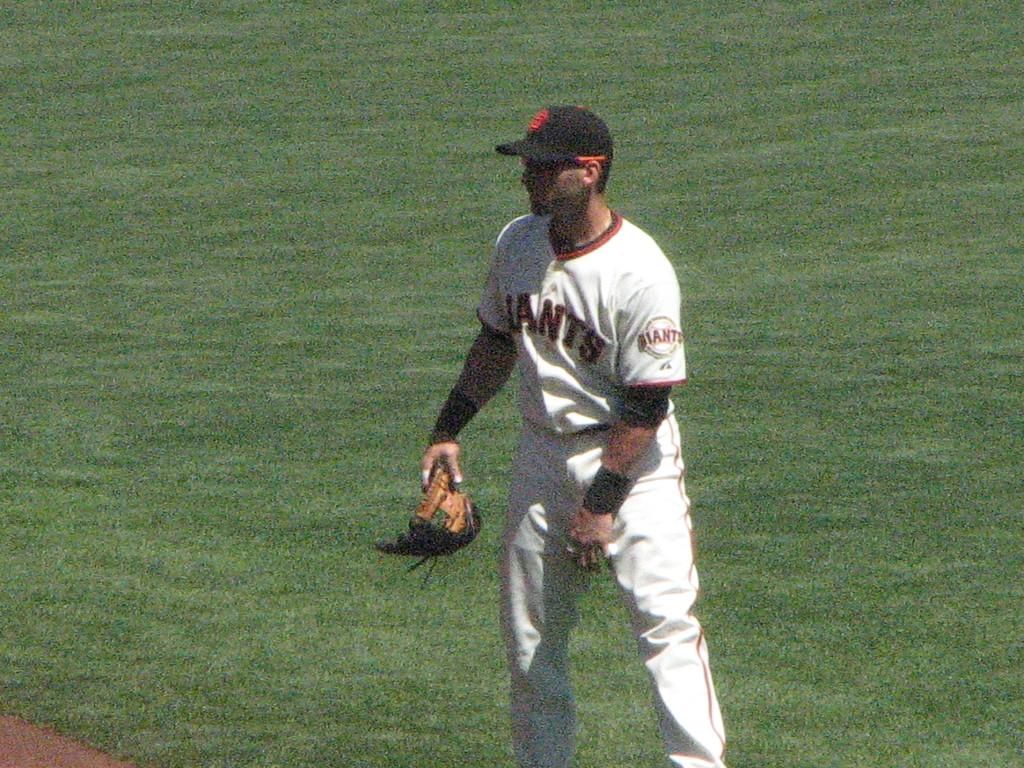What team does he play for?
Your answer should be very brief. Giants. 